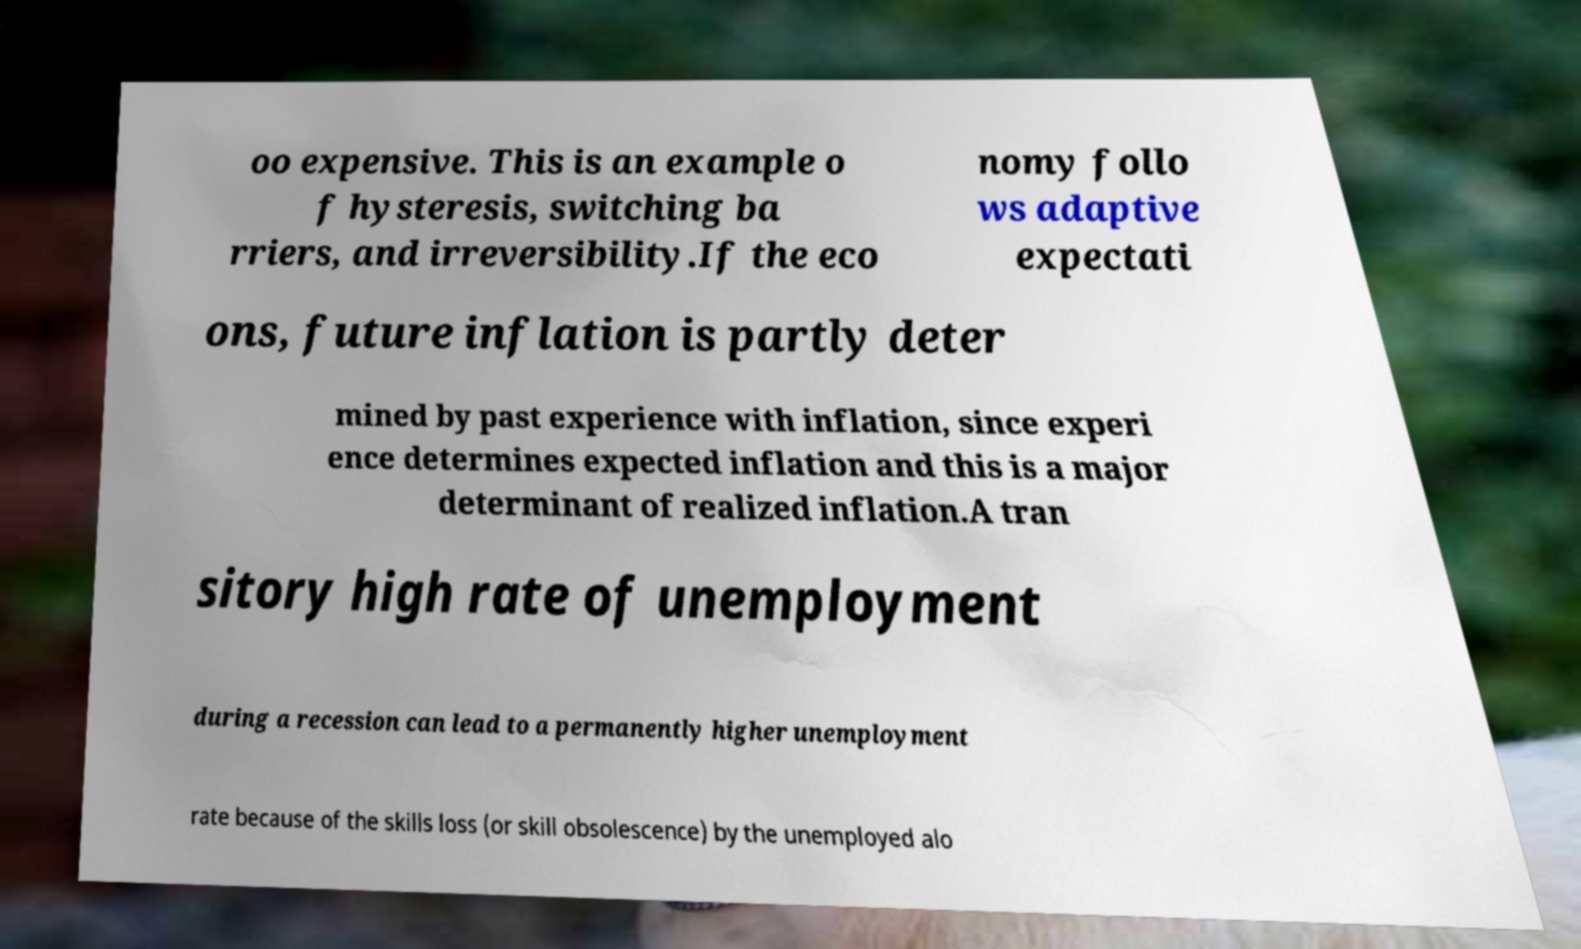Please identify and transcribe the text found in this image. oo expensive. This is an example o f hysteresis, switching ba rriers, and irreversibility.If the eco nomy follo ws adaptive expectati ons, future inflation is partly deter mined by past experience with inflation, since experi ence determines expected inflation and this is a major determinant of realized inflation.A tran sitory high rate of unemployment during a recession can lead to a permanently higher unemployment rate because of the skills loss (or skill obsolescence) by the unemployed alo 